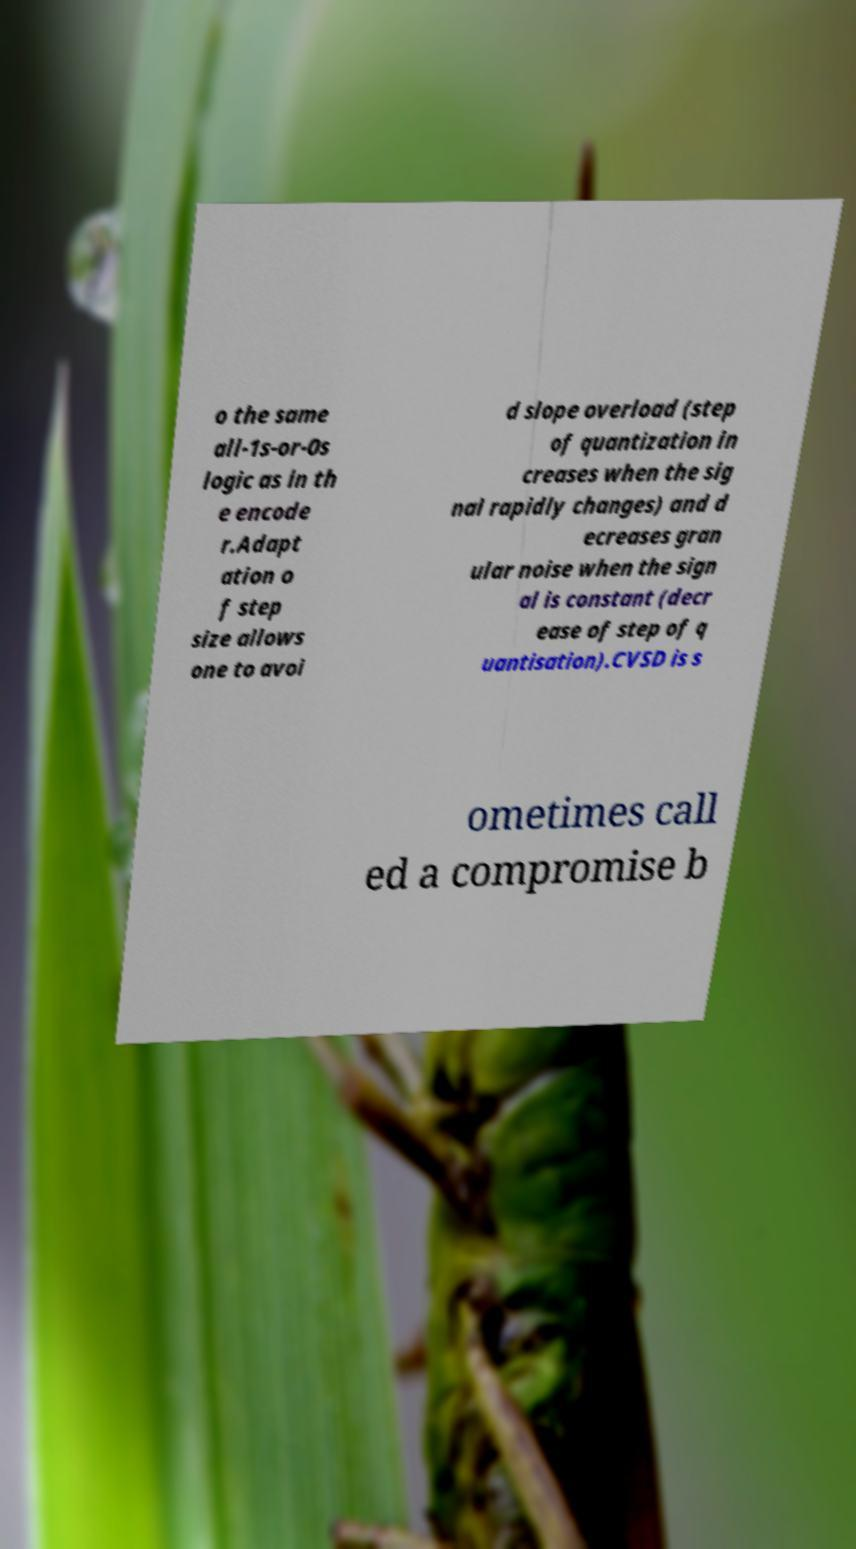There's text embedded in this image that I need extracted. Can you transcribe it verbatim? o the same all-1s-or-0s logic as in th e encode r.Adapt ation o f step size allows one to avoi d slope overload (step of quantization in creases when the sig nal rapidly changes) and d ecreases gran ular noise when the sign al is constant (decr ease of step of q uantisation).CVSD is s ometimes call ed a compromise b 